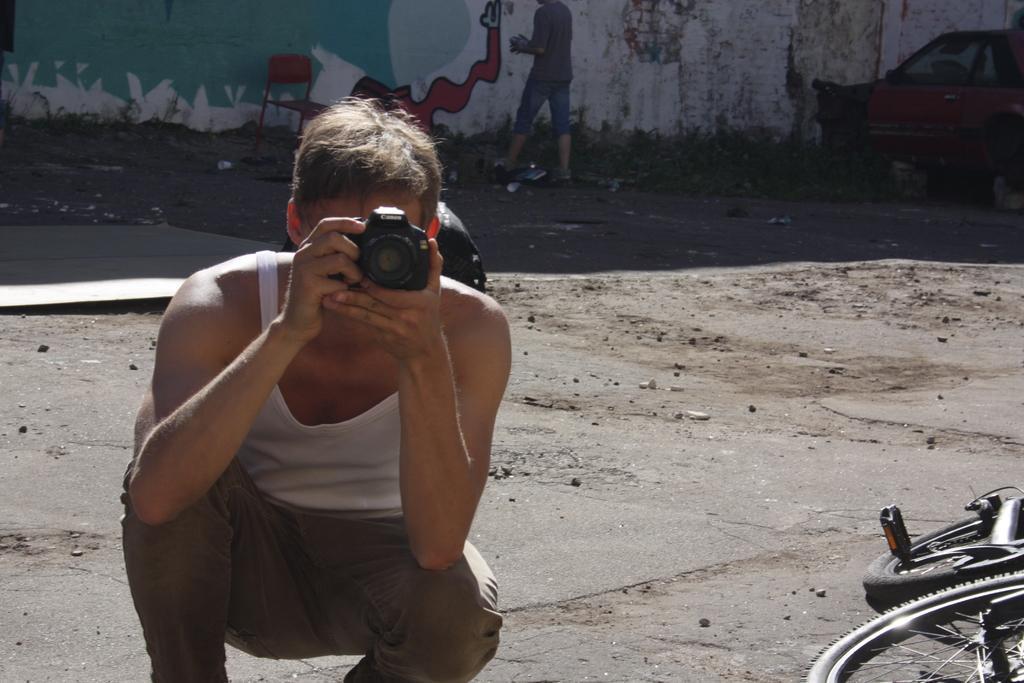Describe this image in one or two sentences. This picture shows a man holding a camera and taking a picture we see a chair and a bicycle and a man standing 